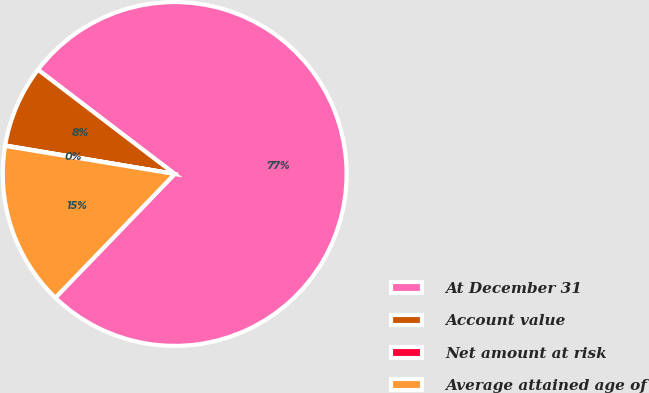Convert chart. <chart><loc_0><loc_0><loc_500><loc_500><pie_chart><fcel>At December 31<fcel>Account value<fcel>Net amount at risk<fcel>Average attained age of<nl><fcel>76.84%<fcel>7.72%<fcel>0.04%<fcel>15.4%<nl></chart> 